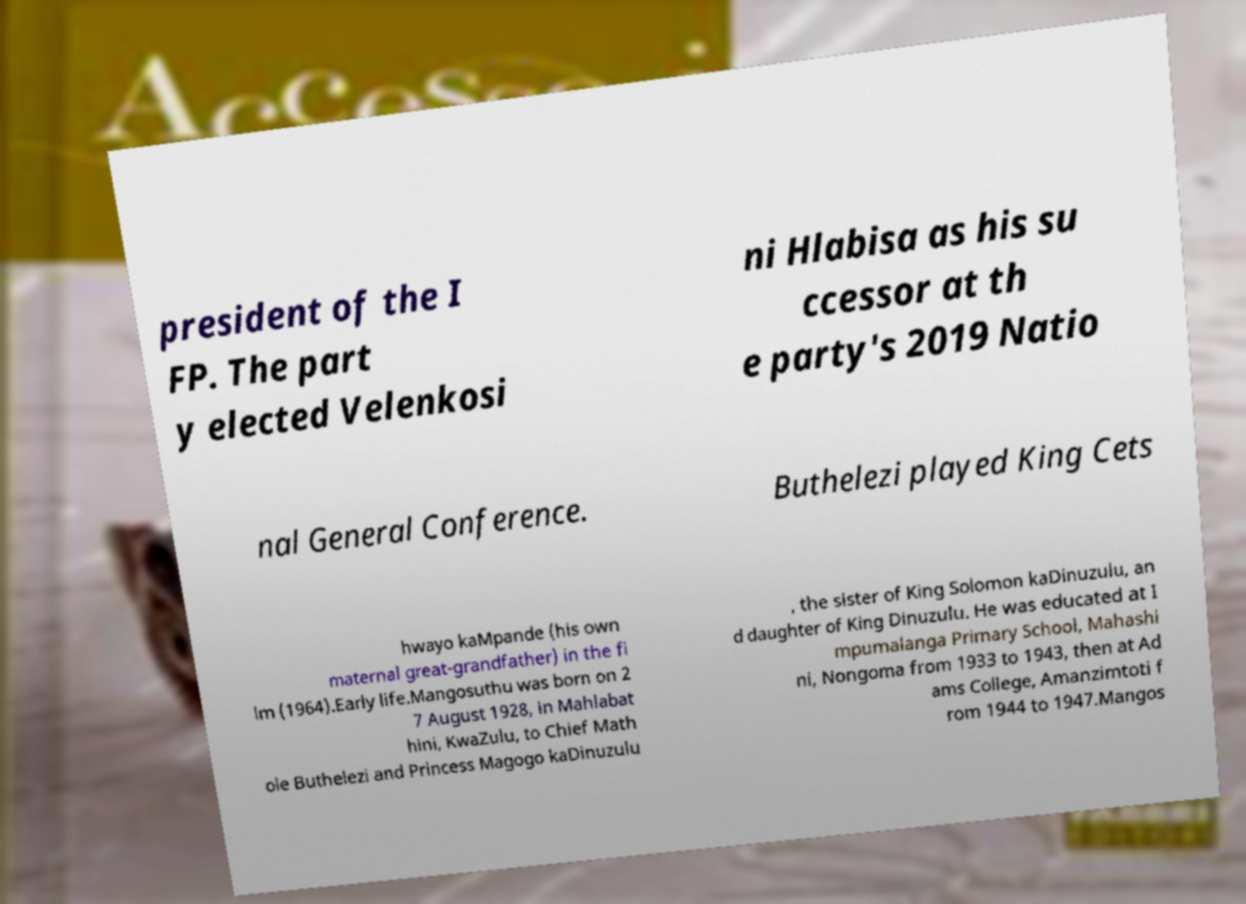Please read and relay the text visible in this image. What does it say? president of the I FP. The part y elected Velenkosi ni Hlabisa as his su ccessor at th e party's 2019 Natio nal General Conference. Buthelezi played King Cets hwayo kaMpande (his own maternal great-grandfather) in the fi lm (1964).Early life.Mangosuthu was born on 2 7 August 1928, in Mahlabat hini, KwaZulu, to Chief Math ole Buthelezi and Princess Magogo kaDinuzulu , the sister of King Solomon kaDinuzulu, an d daughter of King Dinuzulu. He was educated at I mpumalanga Primary School, Mahashi ni, Nongoma from 1933 to 1943, then at Ad ams College, Amanzimtoti f rom 1944 to 1947.Mangos 